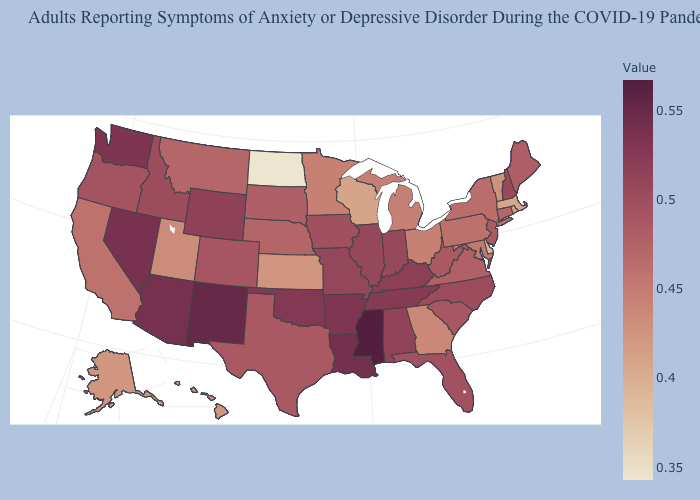Does Maryland have a lower value than Indiana?
Concise answer only. Yes. Does New Hampshire have the lowest value in the Northeast?
Answer briefly. No. Among the states that border Kansas , which have the lowest value?
Answer briefly. Nebraska. Among the states that border South Dakota , which have the highest value?
Quick response, please. Wyoming. Is the legend a continuous bar?
Be succinct. Yes. 